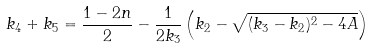<formula> <loc_0><loc_0><loc_500><loc_500>k _ { 4 } + k _ { 5 } = \frac { 1 - 2 n } { 2 } - \frac { 1 } { 2 k _ { 3 } } \left ( k _ { 2 } - \sqrt { ( k _ { 3 } - k _ { 2 } ) ^ { 2 } - 4 A } \right )</formula> 